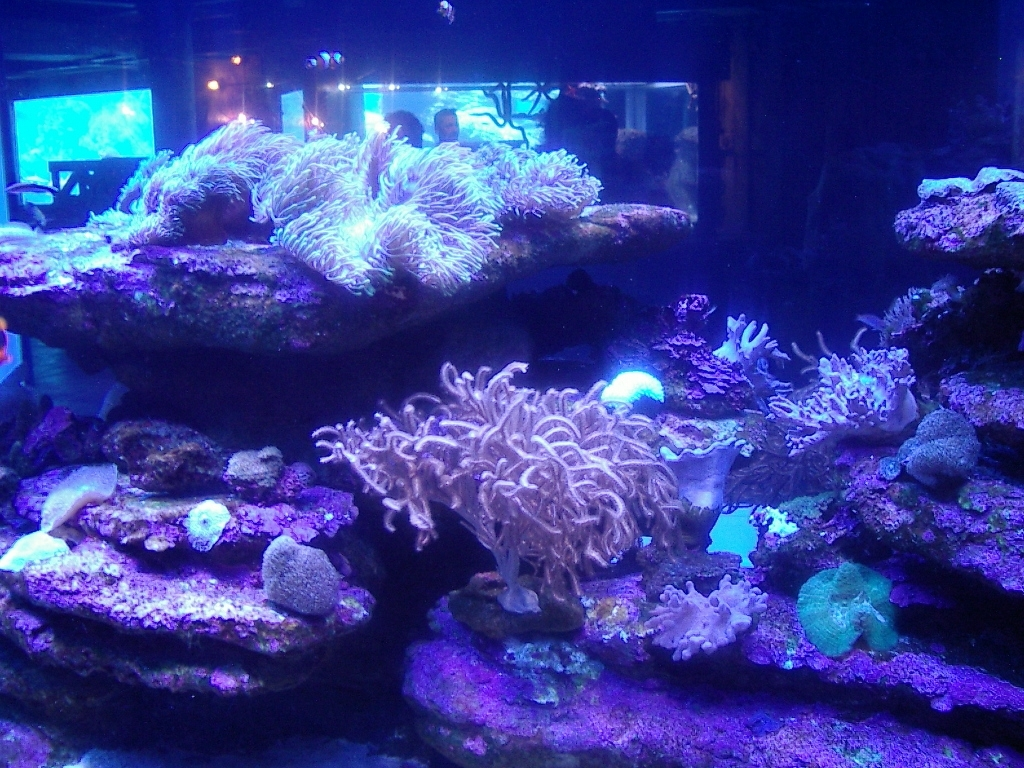Are these corals healthy, and how can you assess their health in a still image? Assessing coral health from a still image can be challenging, but healthy corals typically display vivid colors, which are a sign of the presence of symbiotic algae called zooxanthellae. The corals in this image appear to exhibit bright coloring and full, extended polyps, which can be indicators of good health. However, without more information, it's difficult to make a definitive assessment. 